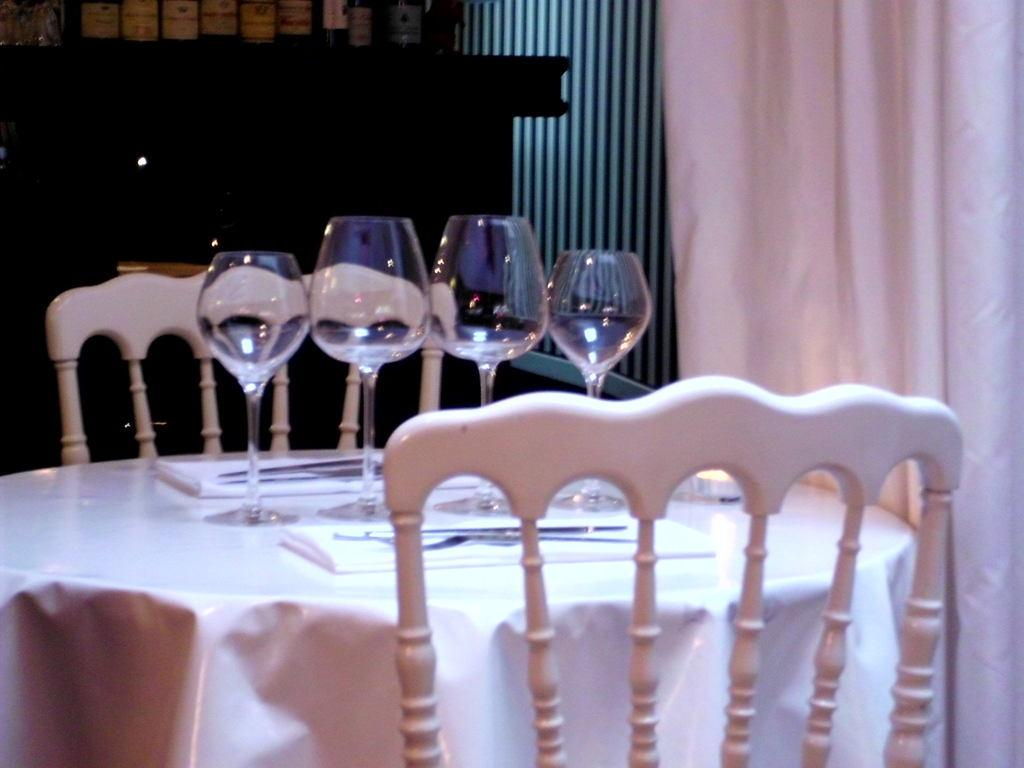How many glasses are on the table in the image? There are four glasses on a table in the image. What type of furniture is present in the image? There are two chairs in the image. Can you see the toes of the person sitting on the chair in the image? There is no person or toes visible in the image; it only shows four glasses on a table and two chairs. 